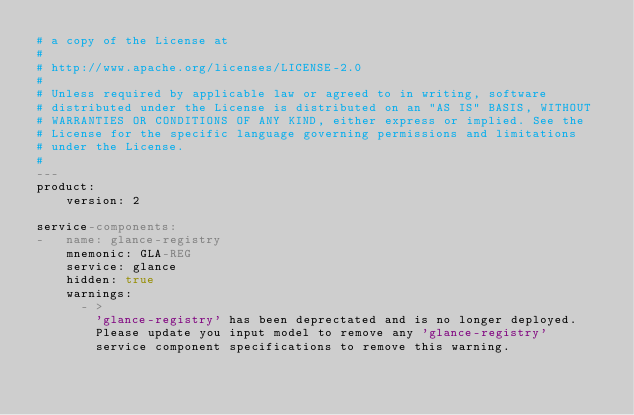Convert code to text. <code><loc_0><loc_0><loc_500><loc_500><_YAML_># a copy of the License at
#
# http://www.apache.org/licenses/LICENSE-2.0
#
# Unless required by applicable law or agreed to in writing, software
# distributed under the License is distributed on an "AS IS" BASIS, WITHOUT
# WARRANTIES OR CONDITIONS OF ANY KIND, either express or implied. See the
# License for the specific language governing permissions and limitations
# under the License.
#
---
product:
    version: 2

service-components:
-   name: glance-registry
    mnemonic: GLA-REG
    service: glance
    hidden: true
    warnings:
      - >
        'glance-registry' has been deprectated and is no longer deployed.
        Please update you input model to remove any 'glance-registry'
        service component specifications to remove this warning.
</code> 